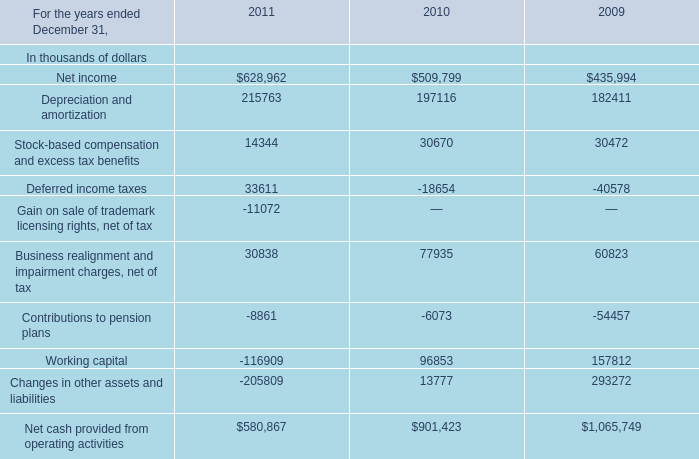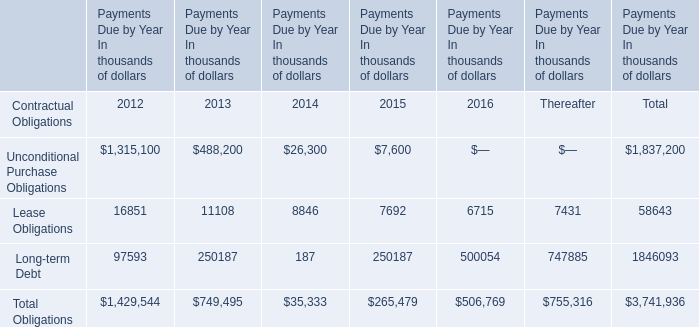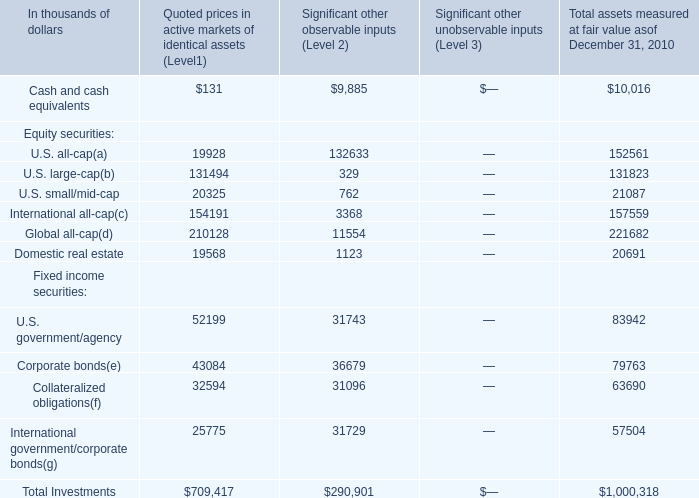How many fixed income securities exceed the average of Fixed income securities in Total assets measured at fair value asof December 31, 2010? 
Computations: ((((83942 + 79763) + 63690) + 57504) / 4)
Answer: 71224.75. 